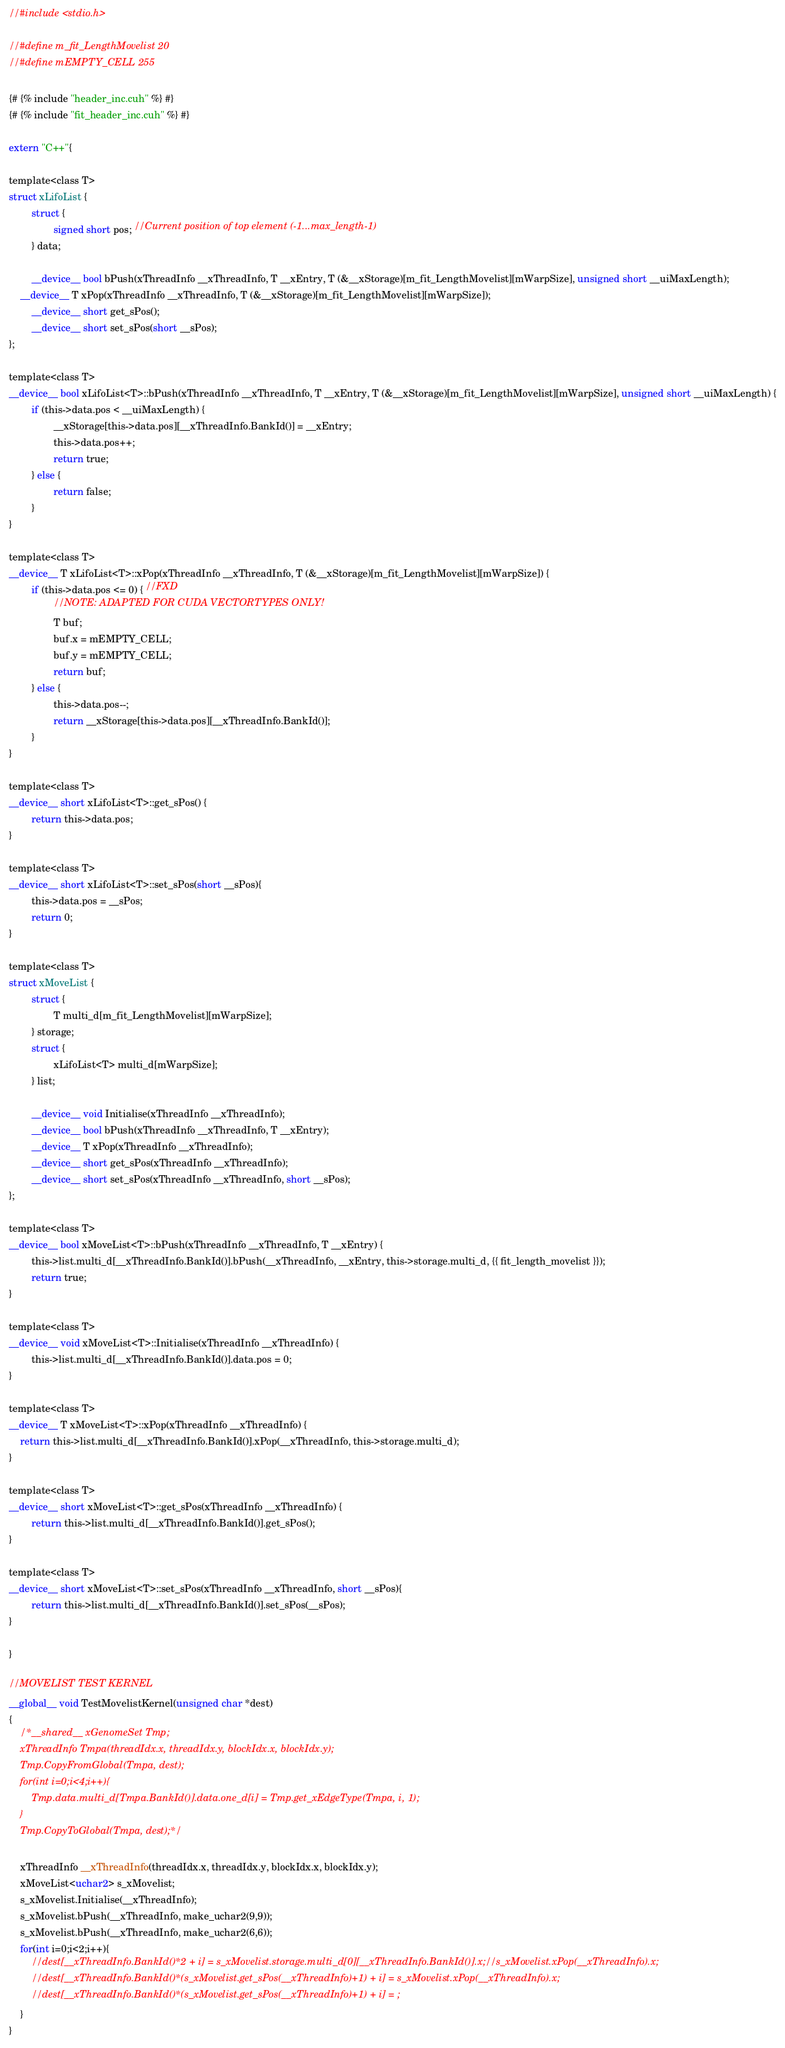Convert code to text. <code><loc_0><loc_0><loc_500><loc_500><_Cuda_>//#include <stdio.h>

//#define m_fit_LengthMovelist 20
//#define mEMPTY_CELL 255

{# {% include "header_inc.cuh" %} #}
{# {% include "fit_header_inc.cuh" %} #}

extern "C++"{

template<class T>
struct xLifoList {
        struct {
                signed short pos; //Current position of top element (-1...max_length-1)
        } data;

        __device__ bool bPush(xThreadInfo __xThreadInfo, T __xEntry, T (&__xStorage)[m_fit_LengthMovelist][mWarpSize], unsigned short __uiMaxLength);
	__device__ T xPop(xThreadInfo __xThreadInfo, T (&__xStorage)[m_fit_LengthMovelist][mWarpSize]);
        __device__ short get_sPos();
        __device__ short set_sPos(short __sPos);
};

template<class T>
__device__ bool xLifoList<T>::bPush(xThreadInfo __xThreadInfo, T __xEntry, T (&__xStorage)[m_fit_LengthMovelist][mWarpSize], unsigned short __uiMaxLength) {
        if (this->data.pos < __uiMaxLength) {
                __xStorage[this->data.pos][__xThreadInfo.BankId()] = __xEntry;
                this->data.pos++;
                return true;
        } else {
                return false;
        }
}

template<class T>
__device__ T xLifoList<T>::xPop(xThreadInfo __xThreadInfo, T (&__xStorage)[m_fit_LengthMovelist][mWarpSize]) {
        if (this->data.pos <= 0) { //FXD
                //NOTE: ADAPTED FOR CUDA VECTORTYPES ONLY!
                T buf;
                buf.x = mEMPTY_CELL;
                buf.y = mEMPTY_CELL;
                return buf;
        } else {
                this->data.pos--;
                return __xStorage[this->data.pos][__xThreadInfo.BankId()];
        }
}

template<class T>
__device__ short xLifoList<T>::get_sPos() {
        return this->data.pos;
}

template<class T>
__device__ short xLifoList<T>::set_sPos(short __sPos){
        this->data.pos = __sPos;
        return 0;
}

template<class T>
struct xMoveList {
        struct {
                T multi_d[m_fit_LengthMovelist][mWarpSize];
        } storage;
        struct {
                xLifoList<T> multi_d[mWarpSize];
        } list;

        __device__ void Initialise(xThreadInfo __xThreadInfo);
        __device__ bool bPush(xThreadInfo __xThreadInfo, T __xEntry);
        __device__ T xPop(xThreadInfo __xThreadInfo);
        __device__ short get_sPos(xThreadInfo __xThreadInfo);
        __device__ short set_sPos(xThreadInfo __xThreadInfo, short __sPos);
};

template<class T>
__device__ bool xMoveList<T>::bPush(xThreadInfo __xThreadInfo, T __xEntry) {
        this->list.multi_d[__xThreadInfo.BankId()].bPush(__xThreadInfo, __xEntry, this->storage.multi_d, {{ fit_length_movelist }});
        return true;
}

template<class T>
__device__ void xMoveList<T>::Initialise(xThreadInfo __xThreadInfo) {
        this->list.multi_d[__xThreadInfo.BankId()].data.pos = 0;
}

template<class T>
__device__ T xMoveList<T>::xPop(xThreadInfo __xThreadInfo) {
	return this->list.multi_d[__xThreadInfo.BankId()].xPop(__xThreadInfo, this->storage.multi_d);
}

template<class T>
__device__ short xMoveList<T>::get_sPos(xThreadInfo __xThreadInfo) {
        return this->list.multi_d[__xThreadInfo.BankId()].get_sPos();
}

template<class T>
__device__ short xMoveList<T>::set_sPos(xThreadInfo __xThreadInfo, short __sPos){
        return this->list.multi_d[__xThreadInfo.BankId()].set_sPos(__sPos);
}

}

//MOVELIST TEST KERNEL
__global__ void TestMovelistKernel(unsigned char *dest)
{
    /*__shared__ xGenomeSet Tmp;
    xThreadInfo Tmpa(threadIdx.x, threadIdx.y, blockIdx.x, blockIdx.y);
    Tmp.CopyFromGlobal(Tmpa, dest);   
    for(int i=0;i<4;i++){
        Tmp.data.multi_d[Tmpa.BankId()].data.one_d[i] = Tmp.get_xEdgeType(Tmpa, i, 1);
    }
    Tmp.CopyToGlobal(Tmpa, dest);*/

    xThreadInfo __xThreadInfo(threadIdx.x, threadIdx.y, blockIdx.x, blockIdx.y); 
    xMoveList<uchar2> s_xMovelist;
    s_xMovelist.Initialise(__xThreadInfo);
    s_xMovelist.bPush(__xThreadInfo, make_uchar2(9,9));
    s_xMovelist.bPush(__xThreadInfo, make_uchar2(6,6));
    for(int i=0;i<2;i++){
        //dest[__xThreadInfo.BankId()*2 + i] = s_xMovelist.storage.multi_d[0][__xThreadInfo.BankId()].x;//s_xMovelist.xPop(__xThreadInfo).x;
        //dest[__xThreadInfo.BankId()*(s_xMovelist.get_sPos(__xThreadInfo)+1) + i] = s_xMovelist.xPop(__xThreadInfo).x;
        //dest[__xThreadInfo.BankId()*(s_xMovelist.get_sPos(__xThreadInfo)+1) + i] = ;
    }
}
</code> 